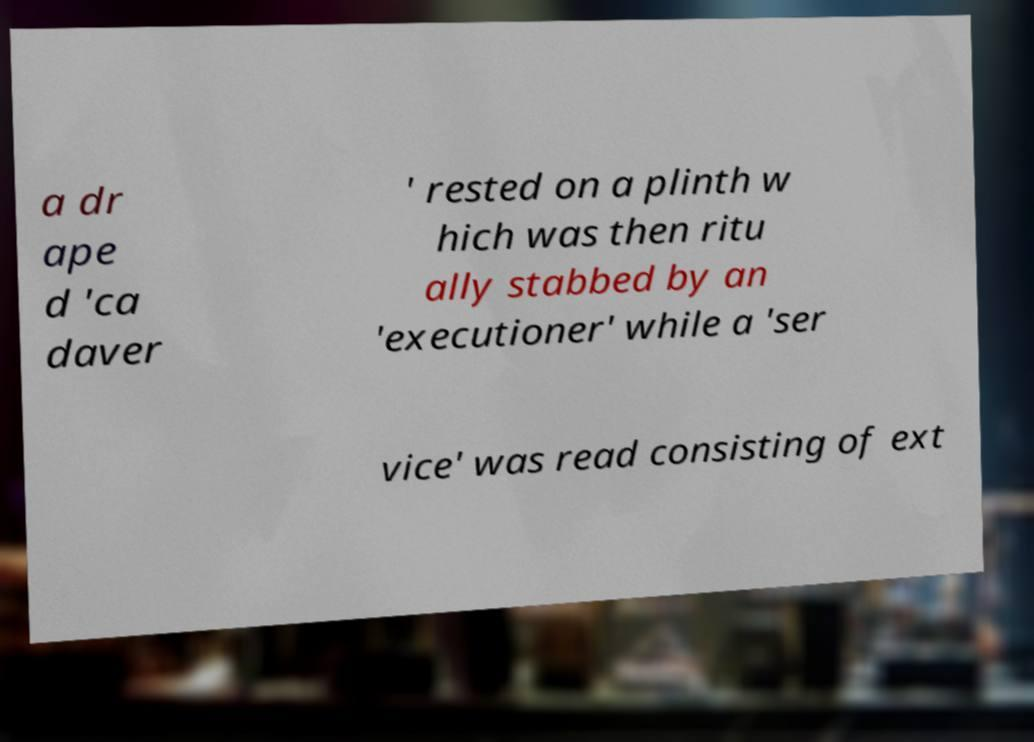Please read and relay the text visible in this image. What does it say? a dr ape d 'ca daver ' rested on a plinth w hich was then ritu ally stabbed by an 'executioner' while a 'ser vice' was read consisting of ext 